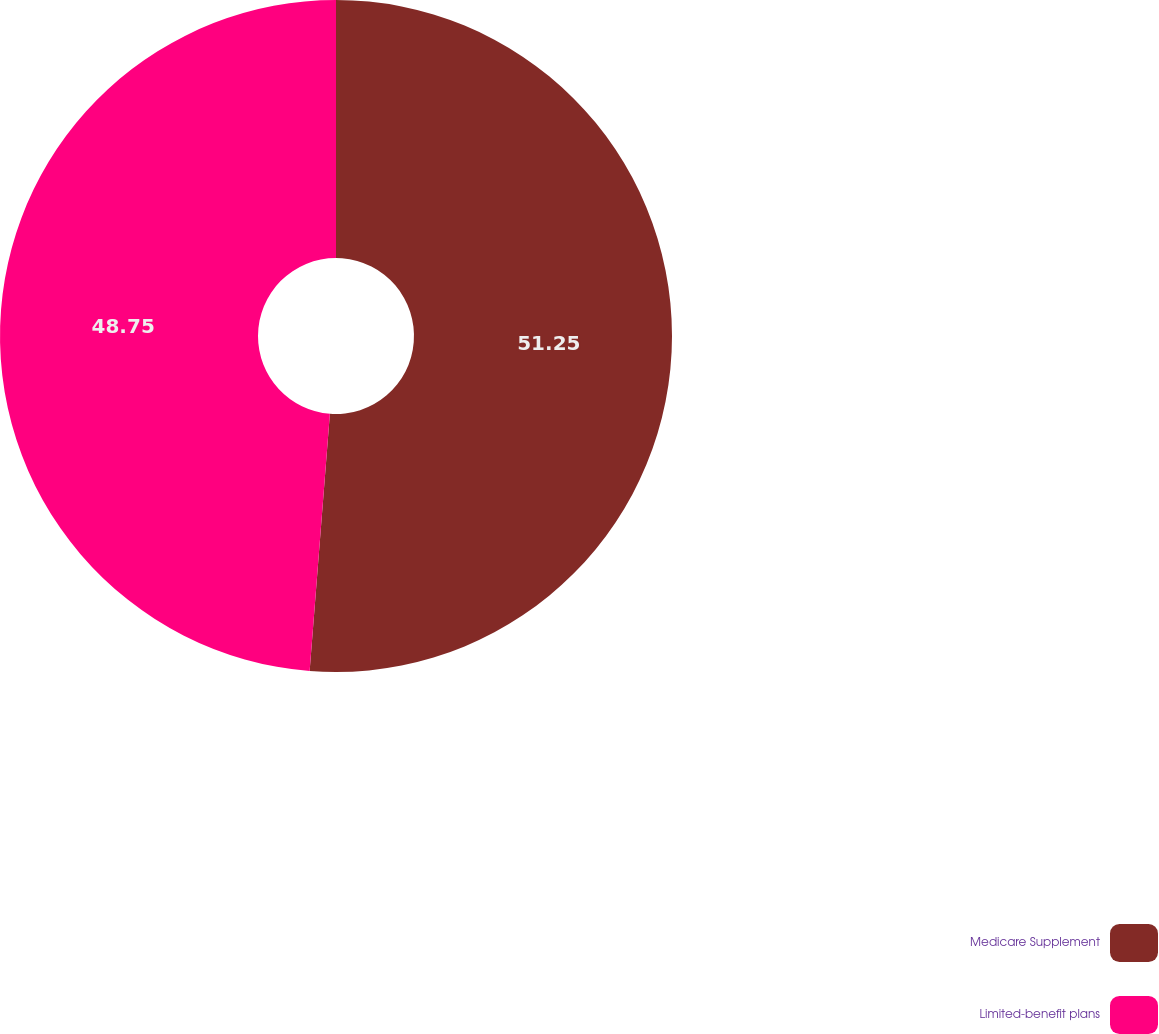Convert chart. <chart><loc_0><loc_0><loc_500><loc_500><pie_chart><fcel>Medicare Supplement<fcel>Limited-benefit plans<nl><fcel>51.25%<fcel>48.75%<nl></chart> 